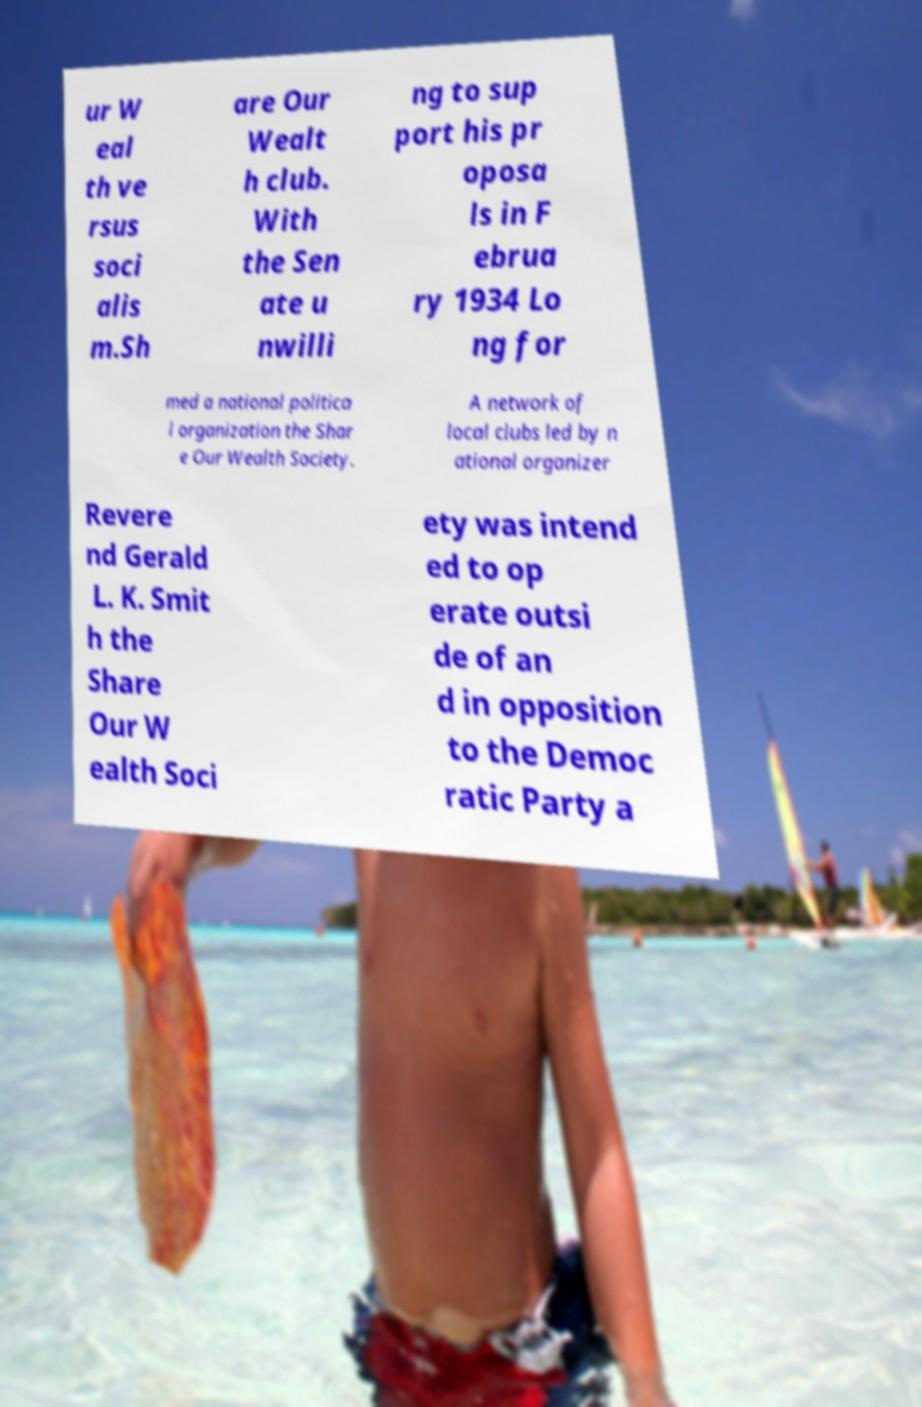I need the written content from this picture converted into text. Can you do that? ur W eal th ve rsus soci alis m.Sh are Our Wealt h club. With the Sen ate u nwilli ng to sup port his pr oposa ls in F ebrua ry 1934 Lo ng for med a national politica l organization the Shar e Our Wealth Society. A network of local clubs led by n ational organizer Revere nd Gerald L. K. Smit h the Share Our W ealth Soci ety was intend ed to op erate outsi de of an d in opposition to the Democ ratic Party a 